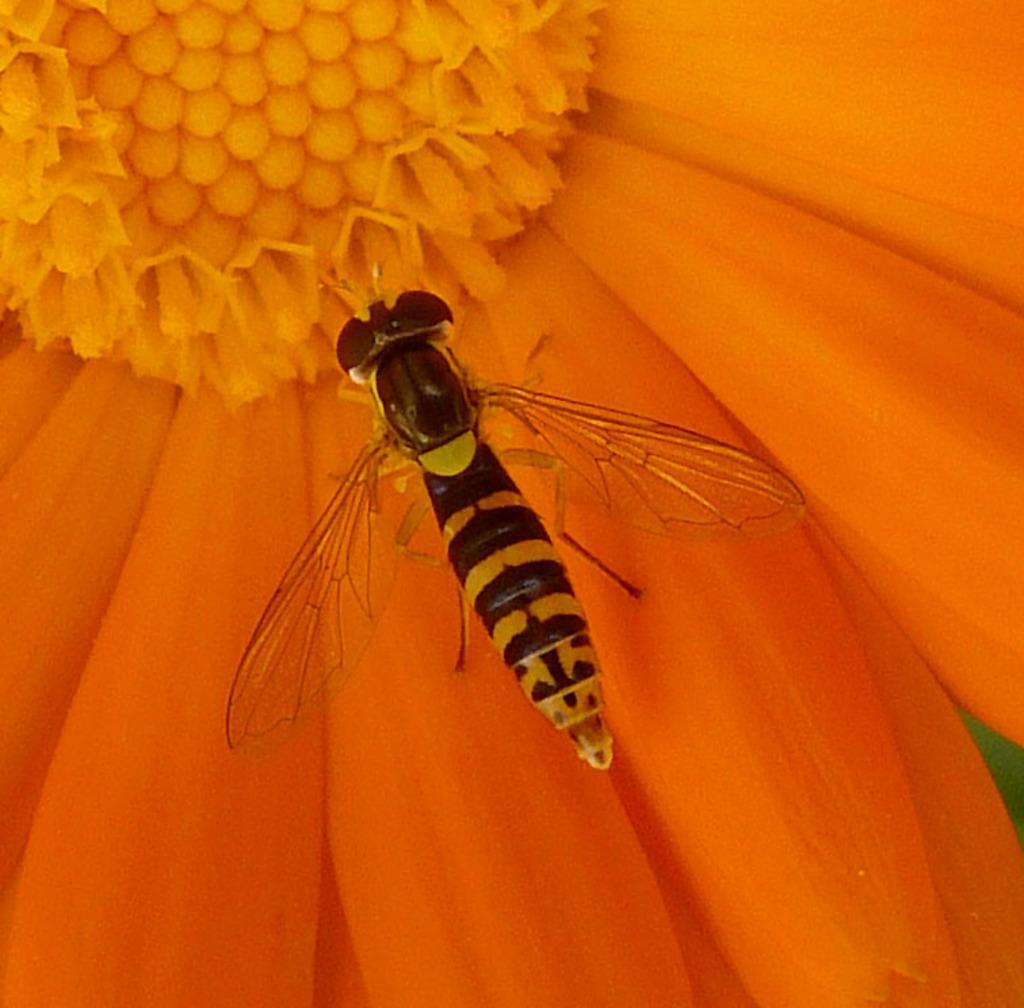Describe this image in one or two sentences. In this image there is a bee on a flower. 